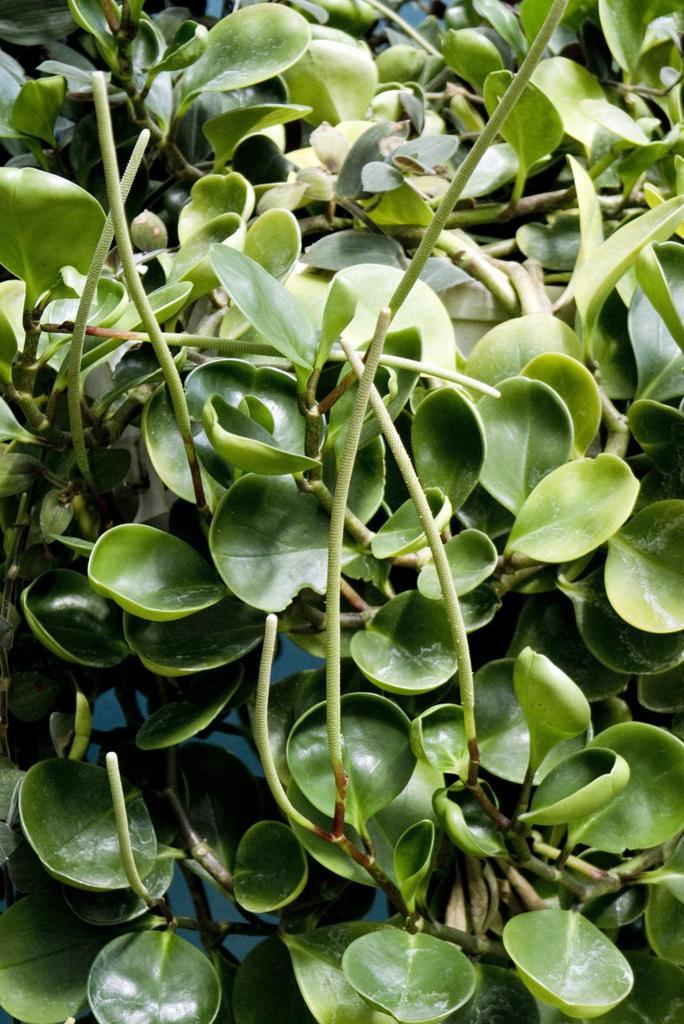What type of plant is in the image? There is a water plant in the image. How far away is the book from the water plant in the image? There is no book present in the image, so it is not possible to determine the distance between a book and the water plant. 